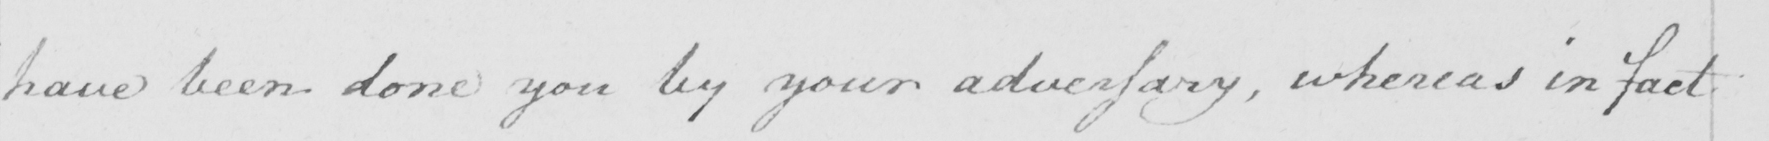What is written in this line of handwriting? have been done you by your adversary, whereas in fact 